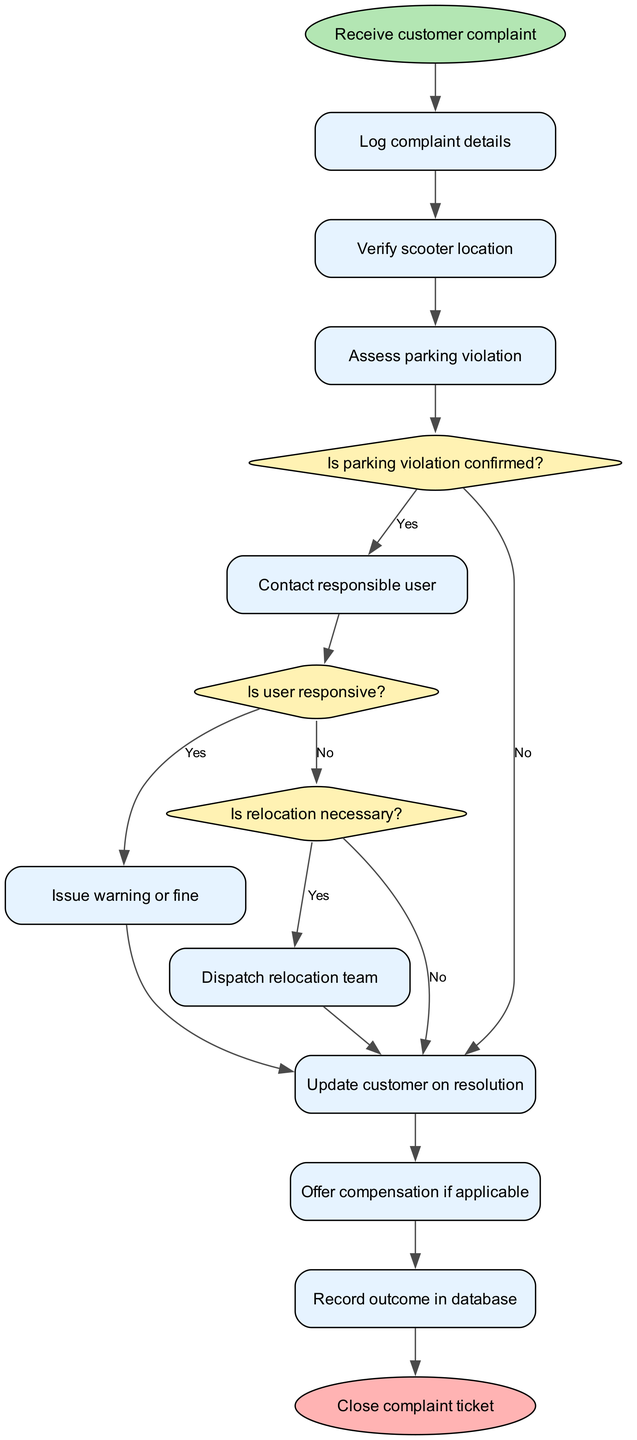What's the start node in the flow chart? The start node in the flow chart is the "Receive customer complaint," which indicates the first step of the protocol for addressing complaints.
Answer: Receive customer complaint How many decision nodes are there in the diagram? The diagram contains three decision nodes: one for confirming a parking violation, one for checking user responsiveness, and one for determining if relocation is necessary.
Answer: 3 What process follows after logging the complaint details? After logging the complaint details, the process moves to the "Verify scooter location," which is the next logical step in handling the complaint.
Answer: Verify scooter location What happens if a parking violation is confirmed? If a parking violation is confirmed, the flow proceeds to contact the responsible user to address the violation, as indicated by the diagram's connections.
Answer: Contact responsible user Which node is reached if the user is not responsive? If the user is not responsive, the process continues to the node labeled "Update customer on resolution," which shows that the complaint process proceeds regardless of user response.
Answer: Update customer on resolution How many nodes come before issuing a warning or fine? There are four nodes before issuing a warning or fine: "Log complaint details," "Verify scooter location," "Assess parking violation," and "Contact responsible user." Each node is a prerequisite for issuing a fine.
Answer: 4 What do we do if relocation is necessary? If relocation is deemed necessary, the process directs to dispatch the relocation team to handle the issue effectively, as shown in the flow chart.
Answer: Dispatch relocation team What is the final step in the complaint resolution protocol? The final step in the protocol is to "Close complaint ticket," which signifies the completion of the complaint handling process.
Answer: Close complaint ticket 